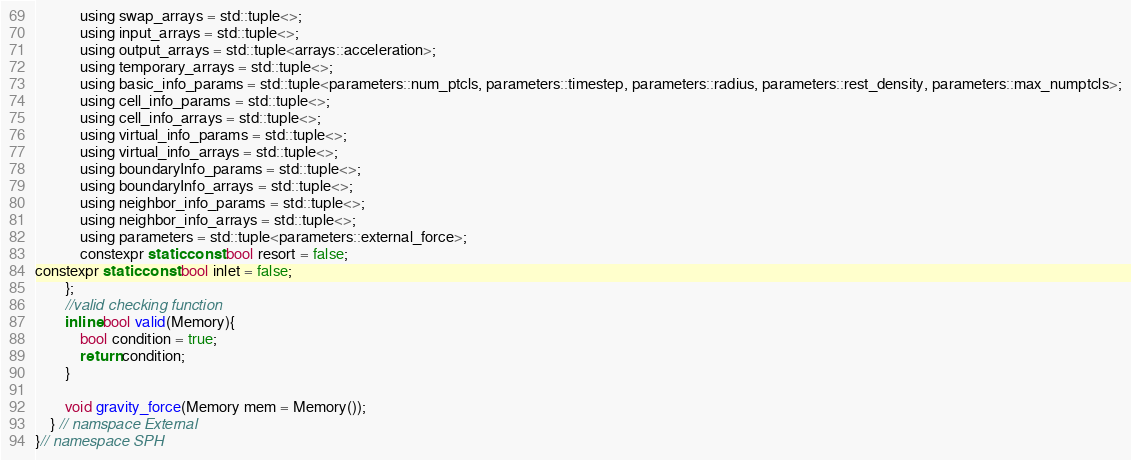<code> <loc_0><loc_0><loc_500><loc_500><_Cuda_>			using swap_arrays = std::tuple<>;
			using input_arrays = std::tuple<>;
			using output_arrays = std::tuple<arrays::acceleration>;
			using temporary_arrays = std::tuple<>;
			using basic_info_params = std::tuple<parameters::num_ptcls, parameters::timestep, parameters::radius, parameters::rest_density, parameters::max_numptcls>;
			using cell_info_params = std::tuple<>;
			using cell_info_arrays = std::tuple<>;
			using virtual_info_params = std::tuple<>;
			using virtual_info_arrays = std::tuple<>;
			using boundaryInfo_params = std::tuple<>;
			using boundaryInfo_arrays = std::tuple<>;
			using neighbor_info_params = std::tuple<>;
			using neighbor_info_arrays = std::tuple<>;
			using parameters = std::tuple<parameters::external_force>;
			constexpr static const bool resort = false;
constexpr static const bool inlet = false;
		};
		//valid checking function
		inline bool valid(Memory){
			bool condition = true;
			return condition;
		}
		
		void gravity_force(Memory mem = Memory());
	} // namspace External
}// namespace SPH
</code> 